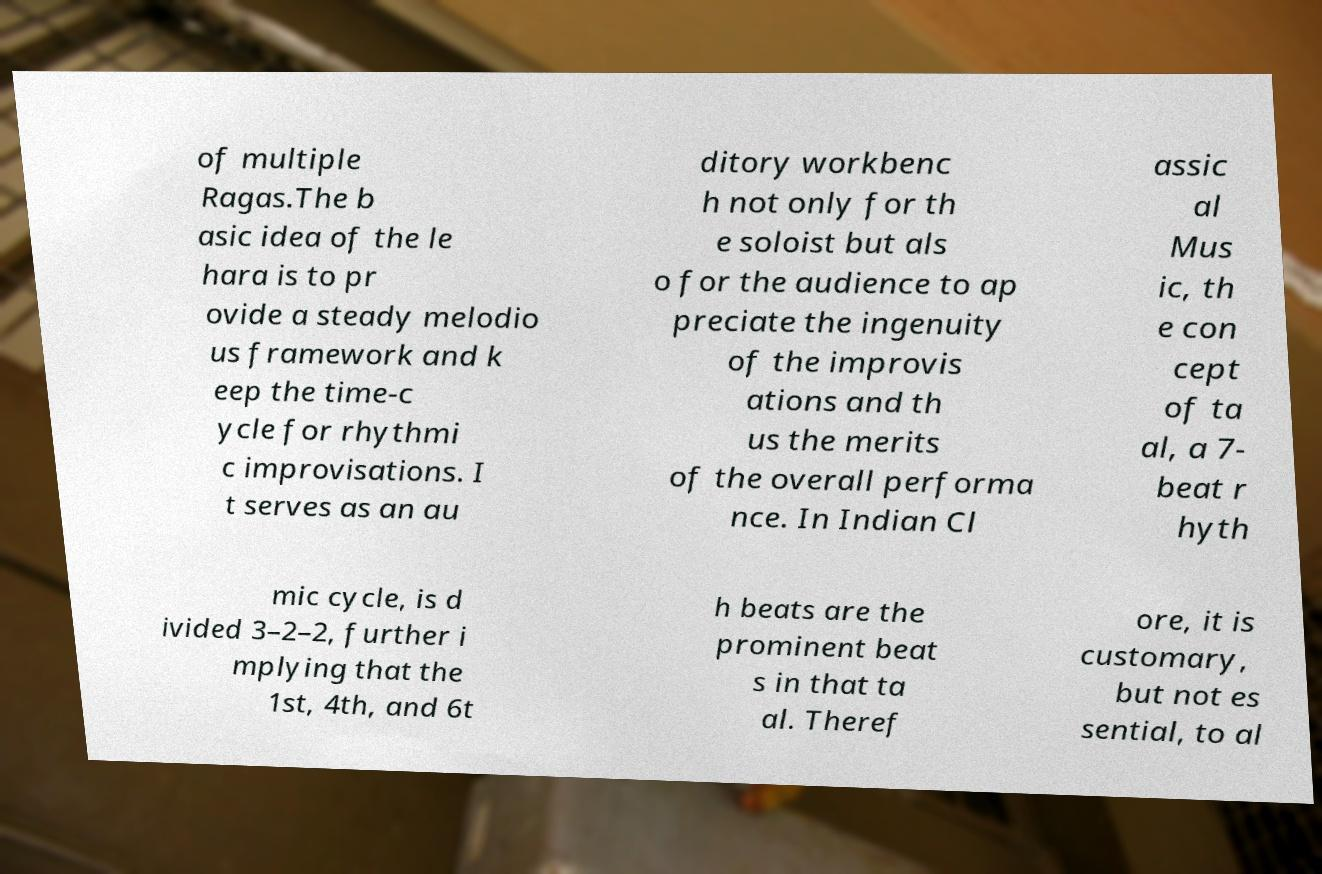Could you extract and type out the text from this image? of multiple Ragas.The b asic idea of the le hara is to pr ovide a steady melodio us framework and k eep the time-c ycle for rhythmi c improvisations. I t serves as an au ditory workbenc h not only for th e soloist but als o for the audience to ap preciate the ingenuity of the improvis ations and th us the merits of the overall performa nce. In Indian Cl assic al Mus ic, th e con cept of ta al, a 7- beat r hyth mic cycle, is d ivided 3–2–2, further i mplying that the 1st, 4th, and 6t h beats are the prominent beat s in that ta al. Theref ore, it is customary, but not es sential, to al 